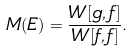<formula> <loc_0><loc_0><loc_500><loc_500>M ( E ) = \frac { W [ g , f ] } { W [ f , f ] } .</formula> 